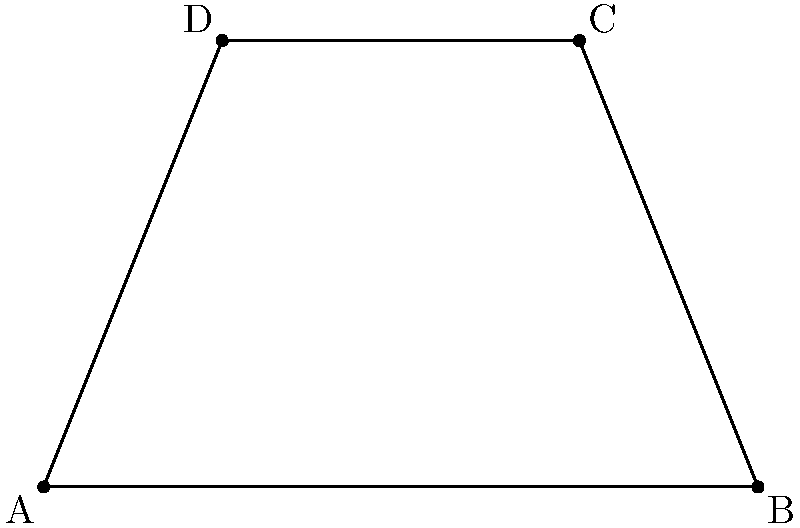A compost pile at your processing facility has a trapezoidal shape when viewed from above. The corners of the pile are represented on a coordinate plane as follows: A(-3,-1), B(5,-1), C(3,4), and D(-1,4). Calculate the area of this compost pile in square units. To calculate the area of the trapezoidal compost pile, we'll use the following steps:

1) The formula for the area of a trapezoid is:
   $$ A = \frac{1}{2}(b_1 + b_2)h $$
   where $b_1$ and $b_2$ are the lengths of the parallel sides and $h$ is the height.

2) From the coordinates, we can see that:
   - The bottom base (AB) runs from x = -3 to x = 5
   - The top base (DC) runs from x = -1 to x = 3
   - The height is the difference in y-coordinates: 4 - (-1) = 5

3) Calculate the length of AB:
   $$ |AB| = 5 - (-3) = 8 $$

4) Calculate the length of DC:
   $$ |DC| = 3 - (-1) = 4 $$

5) Now we can apply the formula:
   $$ A = \frac{1}{2}(8 + 4) \cdot 5 $$
   $$ A = \frac{1}{2}(12) \cdot 5 $$
   $$ A = 6 \cdot 5 = 30 $$

Therefore, the area of the compost pile is 30 square units.
Answer: 30 square units 